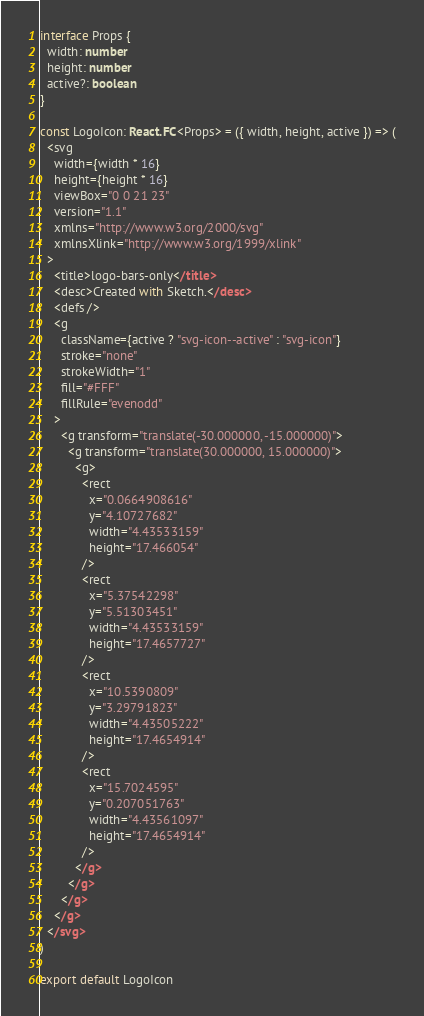<code> <loc_0><loc_0><loc_500><loc_500><_TypeScript_>interface Props {
  width: number
  height: number
  active?: boolean
}

const LogoIcon: React.FC<Props> = ({ width, height, active }) => (
  <svg
    width={width * 16}
    height={height * 16}
    viewBox="0 0 21 23"
    version="1.1"
    xmlns="http://www.w3.org/2000/svg"
    xmlnsXlink="http://www.w3.org/1999/xlink"
  >
    <title>logo-bars-only</title>
    <desc>Created with Sketch.</desc>
    <defs />
    <g
      className={active ? "svg-icon--active" : "svg-icon"}
      stroke="none"
      strokeWidth="1"
      fill="#FFF"
      fillRule="evenodd"
    >
      <g transform="translate(-30.000000, -15.000000)">
        <g transform="translate(30.000000, 15.000000)">
          <g>
            <rect
              x="0.0664908616"
              y="4.10727682"
              width="4.43533159"
              height="17.466054"
            />
            <rect
              x="5.37542298"
              y="5.51303451"
              width="4.43533159"
              height="17.4657727"
            />
            <rect
              x="10.5390809"
              y="3.29791823"
              width="4.43505222"
              height="17.4654914"
            />
            <rect
              x="15.7024595"
              y="0.207051763"
              width="4.43561097"
              height="17.4654914"
            />
          </g>
        </g>
      </g>
    </g>
  </svg>
)

export default LogoIcon
</code> 